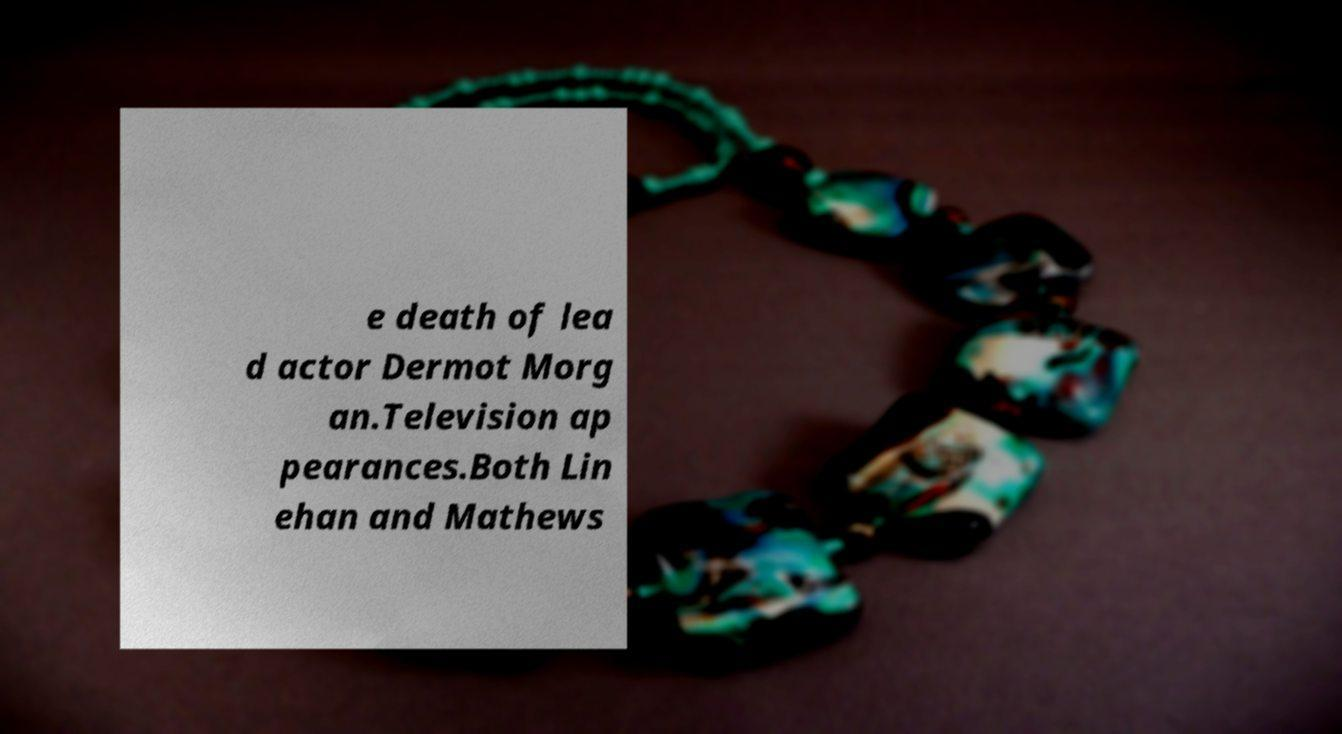For documentation purposes, I need the text within this image transcribed. Could you provide that? e death of lea d actor Dermot Morg an.Television ap pearances.Both Lin ehan and Mathews 